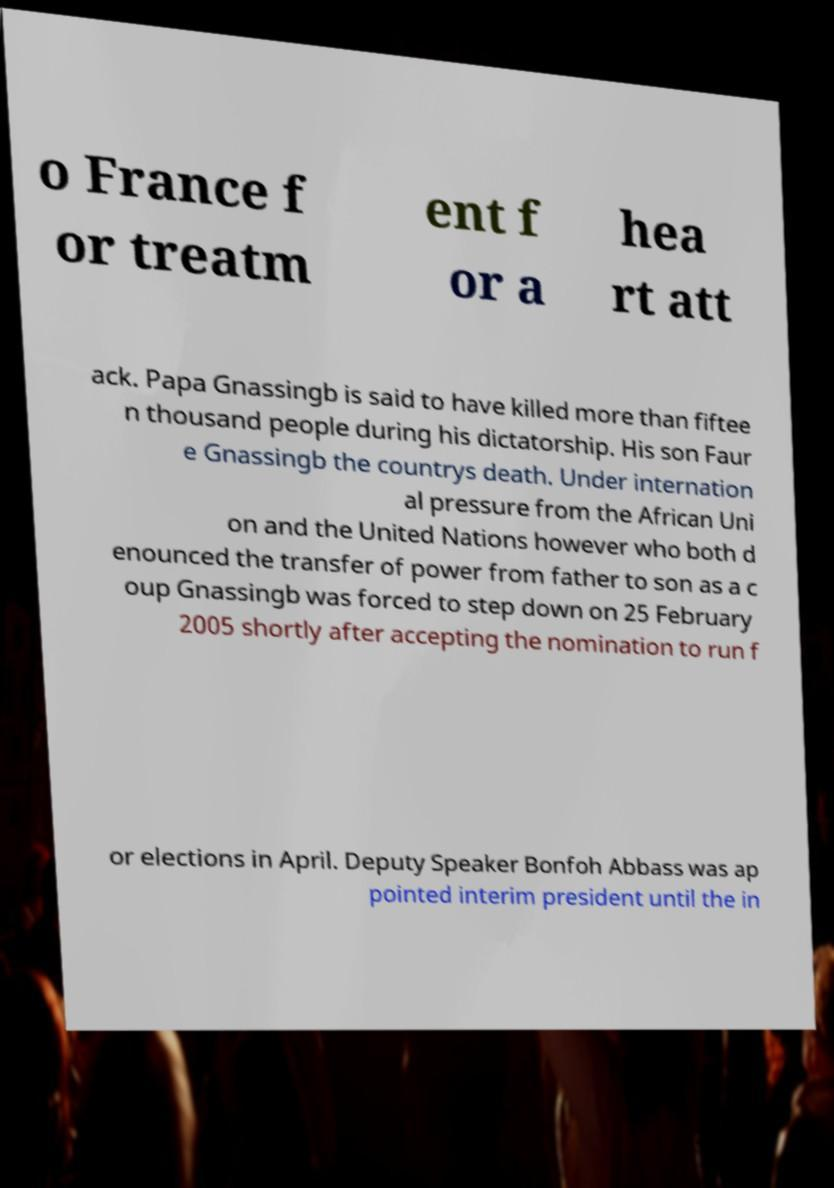Please read and relay the text visible in this image. What does it say? o France f or treatm ent f or a hea rt att ack. Papa Gnassingb is said to have killed more than fiftee n thousand people during his dictatorship. His son Faur e Gnassingb the countrys death. Under internation al pressure from the African Uni on and the United Nations however who both d enounced the transfer of power from father to son as a c oup Gnassingb was forced to step down on 25 February 2005 shortly after accepting the nomination to run f or elections in April. Deputy Speaker Bonfoh Abbass was ap pointed interim president until the in 